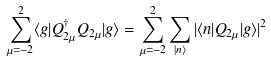<formula> <loc_0><loc_0><loc_500><loc_500>\sum _ { \mu = - 2 } ^ { 2 } \langle g | Q _ { 2 \mu } ^ { \dagger } Q _ { 2 \mu } | g \rangle = \sum _ { \mu = - 2 } ^ { 2 } \sum _ { | n \rangle } | \langle n | Q _ { 2 \mu } | g \rangle | ^ { 2 }</formula> 